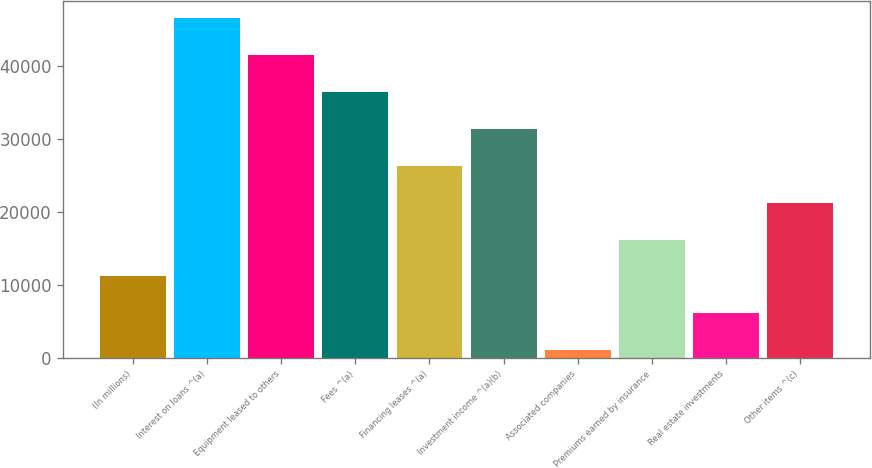Convert chart. <chart><loc_0><loc_0><loc_500><loc_500><bar_chart><fcel>(In millions)<fcel>Interest on loans ^(a)<fcel>Equipment leased to others<fcel>Fees ^(a)<fcel>Financing leases ^(a)<fcel>Investment income ^(a)(b)<fcel>Associated companies<fcel>Premiums earned by insurance<fcel>Real estate investments<fcel>Other items ^(c)<nl><fcel>11143.2<fcel>46619.9<fcel>41551.8<fcel>36483.7<fcel>26347.5<fcel>31415.6<fcel>1007<fcel>16211.3<fcel>6075.1<fcel>21279.4<nl></chart> 